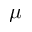<formula> <loc_0><loc_0><loc_500><loc_500>\mu</formula> 